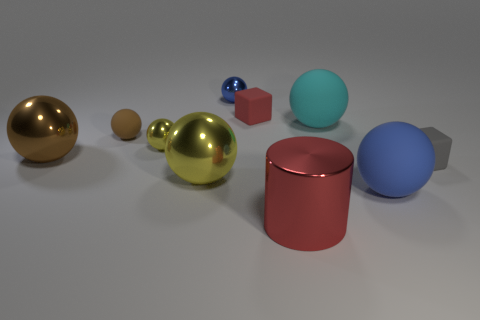What is the shape of the big red object that is the same material as the large yellow thing?
Give a very brief answer. Cylinder. The large sphere that is both behind the gray rubber thing and to the left of the small blue metal thing is what color?
Provide a short and direct response. Brown. Are there any objects of the same color as the tiny matte ball?
Make the answer very short. Yes. What is the color of the metallic sphere in front of the tiny gray object?
Provide a succinct answer. Yellow. There is a blue thing on the right side of the large red thing; is there a large red shiny object on the right side of it?
Offer a terse response. No. There is a big cylinder; is its color the same as the cube that is on the left side of the red metal object?
Offer a very short reply. Yes. Is there a small red ball made of the same material as the big brown sphere?
Give a very brief answer. No. How many small gray blocks are there?
Ensure brevity in your answer.  1. There is a cube that is on the left side of the large thing to the right of the cyan object; what is its material?
Keep it short and to the point. Rubber. The small ball that is made of the same material as the gray object is what color?
Your answer should be compact. Brown. 